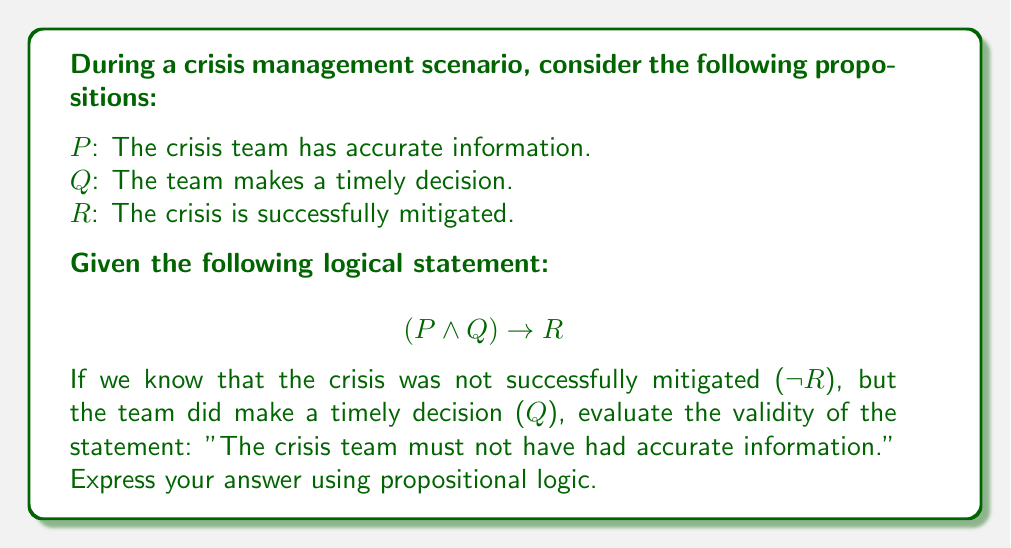Can you solve this math problem? Let's approach this step-by-step using propositional logic:

1) We are given the logical statement: $(P \wedge Q) \rightarrow R$

2) We know two facts:
   - The crisis was not successfully mitigated: $\neg R$
   - The team made a timely decision: $Q$

3) We want to evaluate if it's valid to conclude: $\neg P$ (The crisis team must not have had accurate information)

4) Let's use the method of contraposition. The contrapositive of $(P \wedge Q) \rightarrow R$ is:
   $\neg R \rightarrow \neg(P \wedge Q)$

5) We know $\neg R$ is true, so $\neg(P \wedge Q)$ must also be true.

6) Using De Morgan's law, we can expand $\neg(P \wedge Q)$:
   $\neg(P \wedge Q) \equiv \neg P \vee \neg Q$

7) We know $Q$ is true, so $\neg Q$ is false. For the disjunction $\neg P \vee \neg Q$ to be true when $\neg Q$ is false, $\neg P$ must be true.

8) Therefore, we can conclude that $P$ must be false, or in other words, $\neg P$ is true.

9) This validates the statement: "The crisis team must not have had accurate information."

In propositional logic, we can express this conclusion as:

$$(\neg R \wedge Q) \rightarrow \neg P$$
Answer: $(\neg R \wedge Q) \rightarrow \neg P$ 